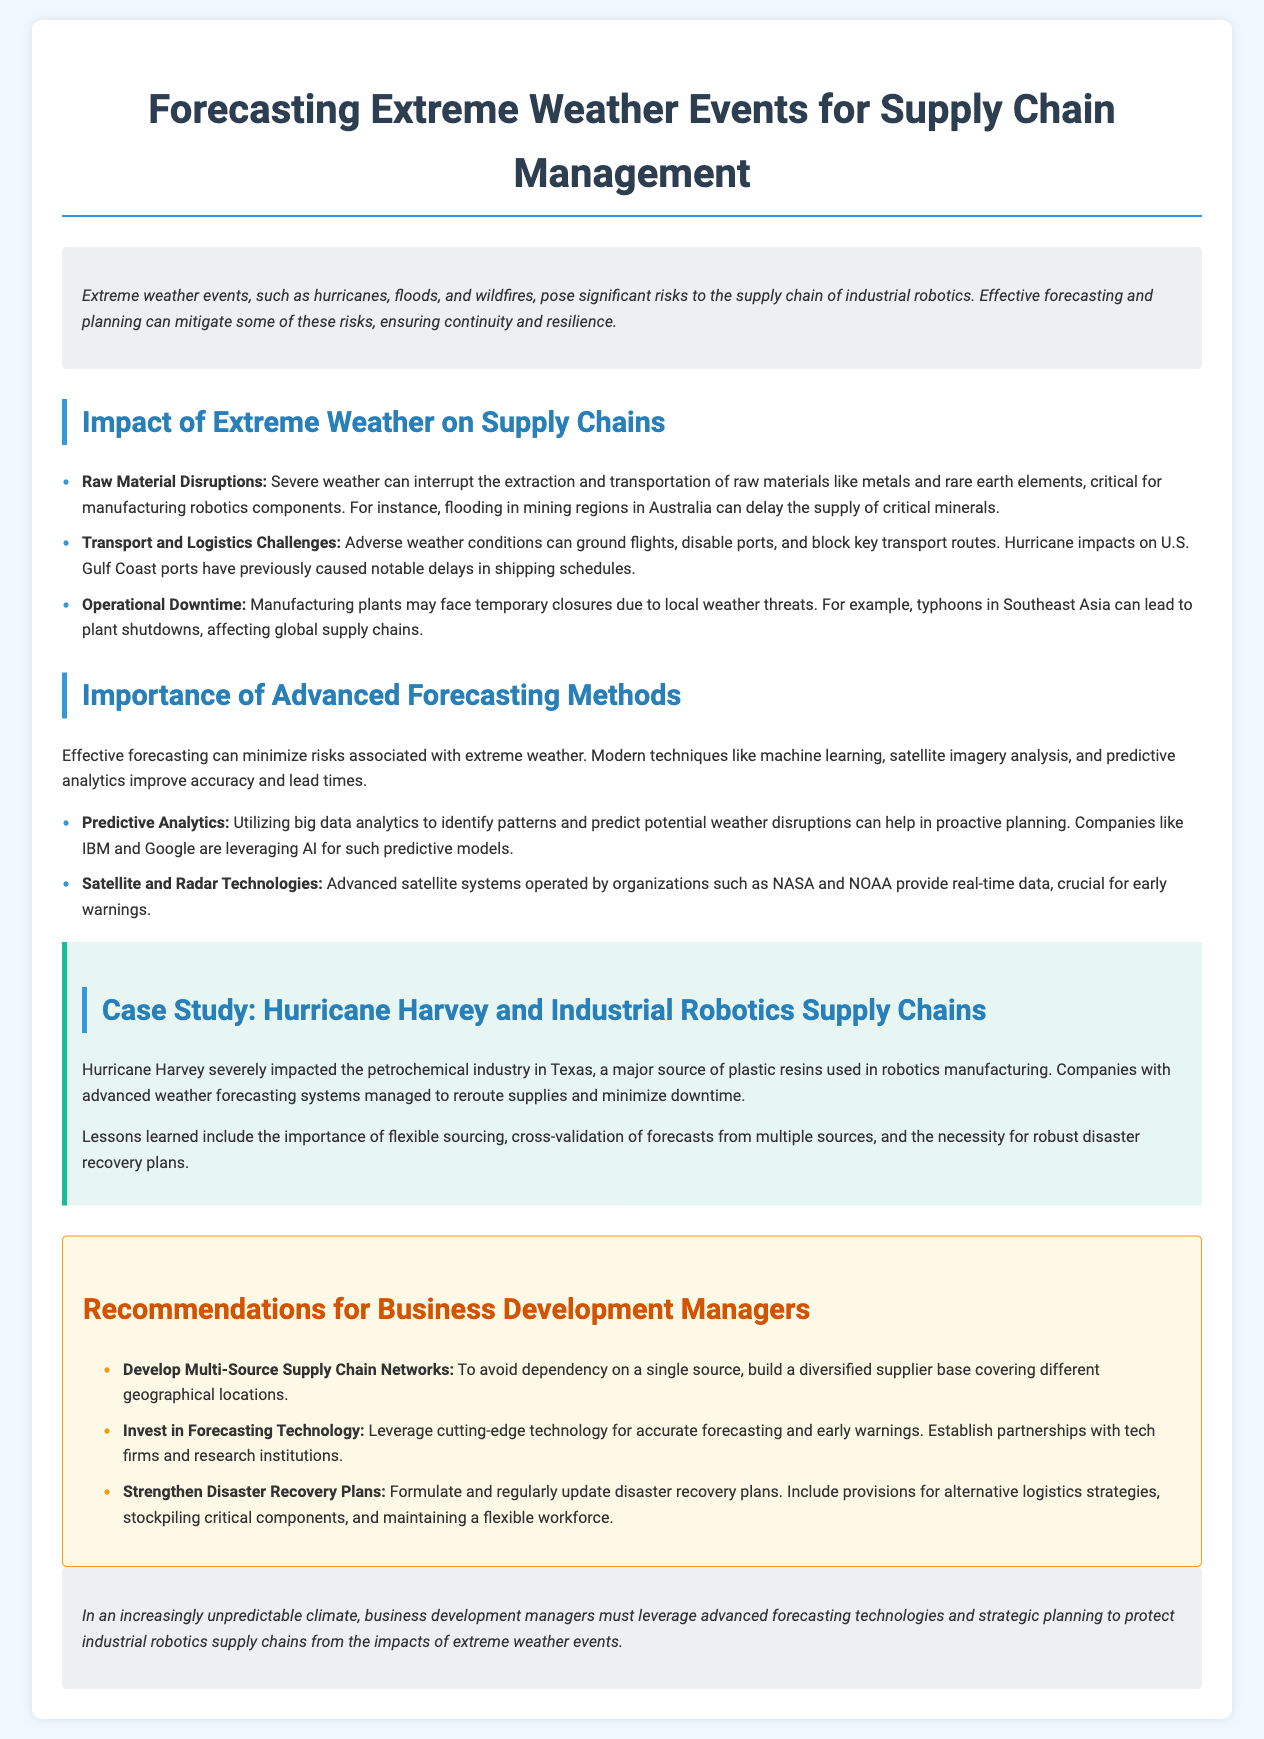What are examples of extreme weather events mentioned? The document lists hurricanes, floods, and wildfires as examples of extreme weather events.
Answer: hurricanes, floods, wildfires What is one impact of severe weather on raw materials? Severe weather can interrupt the extraction and transportation of raw materials critical for manufacturing robotics components.
Answer: Interrupt raw material transport What technology does IBM leverage for predictive models? The document states that IBM utilizes AI for predictive models in forecasting weather disruptions.
Answer: AI How did Hurricane Harvey affect the petrochemical industry? Hurricane Harvey severely impacted the petrochemical industry in Texas, affecting the supply of plastic resins used in robotics manufacturing.
Answer: Severely impacted supply What is a recommendation for strengthening disaster recovery plans? The document suggests formulating and regularly updating disaster recovery plans to include provisions for alternative logistics strategies.
Answer: Update disaster recovery plans What comprehensive approach is suggested for supply chain networks? The document advises developing multi-source supply chain networks to avoid dependency on a single source.
Answer: Multi-source supply chain networks 